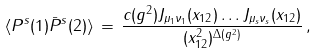Convert formula to latex. <formula><loc_0><loc_0><loc_500><loc_500>\langle P ^ { s } ( 1 ) \bar { P } ^ { s } ( 2 ) \rangle \, = \, \frac { c ( g ^ { 2 } ) J _ { \mu _ { 1 } \nu _ { 1 } } ( x _ { 1 2 } ) \dots J _ { \mu _ { s } \nu _ { s } } ( x _ { 1 2 } ) } { ( x _ { 1 2 } ^ { 2 } ) ^ { \Delta ( g ^ { 2 } ) } } \, ,</formula> 